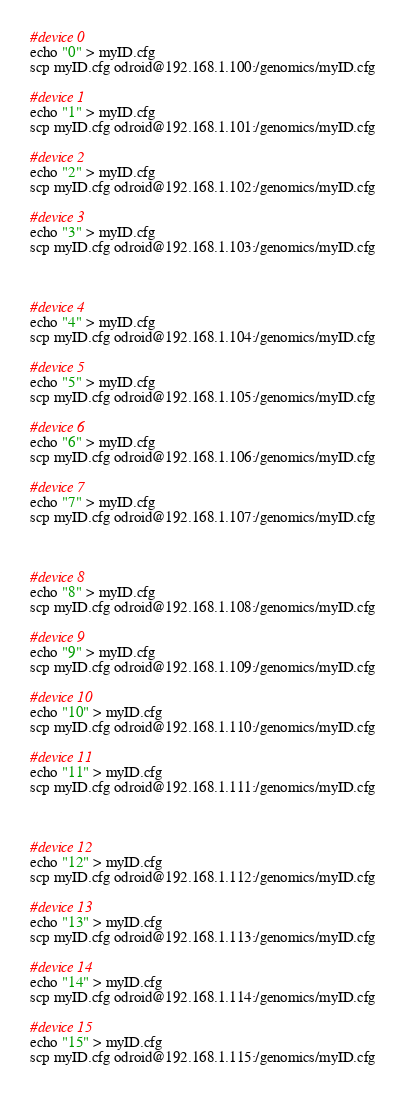Convert code to text. <code><loc_0><loc_0><loc_500><loc_500><_Bash_>#device 0
echo "0" > myID.cfg
scp myID.cfg odroid@192.168.1.100:/genomics/myID.cfg

#device 1
echo "1" > myID.cfg
scp myID.cfg odroid@192.168.1.101:/genomics/myID.cfg

#device 2
echo "2" > myID.cfg
scp myID.cfg odroid@192.168.1.102:/genomics/myID.cfg

#device 3
echo "3" > myID.cfg
scp myID.cfg odroid@192.168.1.103:/genomics/myID.cfg



#device 4
echo "4" > myID.cfg
scp myID.cfg odroid@192.168.1.104:/genomics/myID.cfg

#device 5
echo "5" > myID.cfg
scp myID.cfg odroid@192.168.1.105:/genomics/myID.cfg

#device 6
echo "6" > myID.cfg
scp myID.cfg odroid@192.168.1.106:/genomics/myID.cfg

#device 7
echo "7" > myID.cfg
scp myID.cfg odroid@192.168.1.107:/genomics/myID.cfg



#device 8
echo "8" > myID.cfg
scp myID.cfg odroid@192.168.1.108:/genomics/myID.cfg

#device 9
echo "9" > myID.cfg
scp myID.cfg odroid@192.168.1.109:/genomics/myID.cfg

#device 10
echo "10" > myID.cfg
scp myID.cfg odroid@192.168.1.110:/genomics/myID.cfg

#device 11
echo "11" > myID.cfg
scp myID.cfg odroid@192.168.1.111:/genomics/myID.cfg



#device 12
echo "12" > myID.cfg
scp myID.cfg odroid@192.168.1.112:/genomics/myID.cfg

#device 13
echo "13" > myID.cfg
scp myID.cfg odroid@192.168.1.113:/genomics/myID.cfg

#device 14
echo "14" > myID.cfg
scp myID.cfg odroid@192.168.1.114:/genomics/myID.cfg

#device 15
echo "15" > myID.cfg
scp myID.cfg odroid@192.168.1.115:/genomics/myID.cfg</code> 